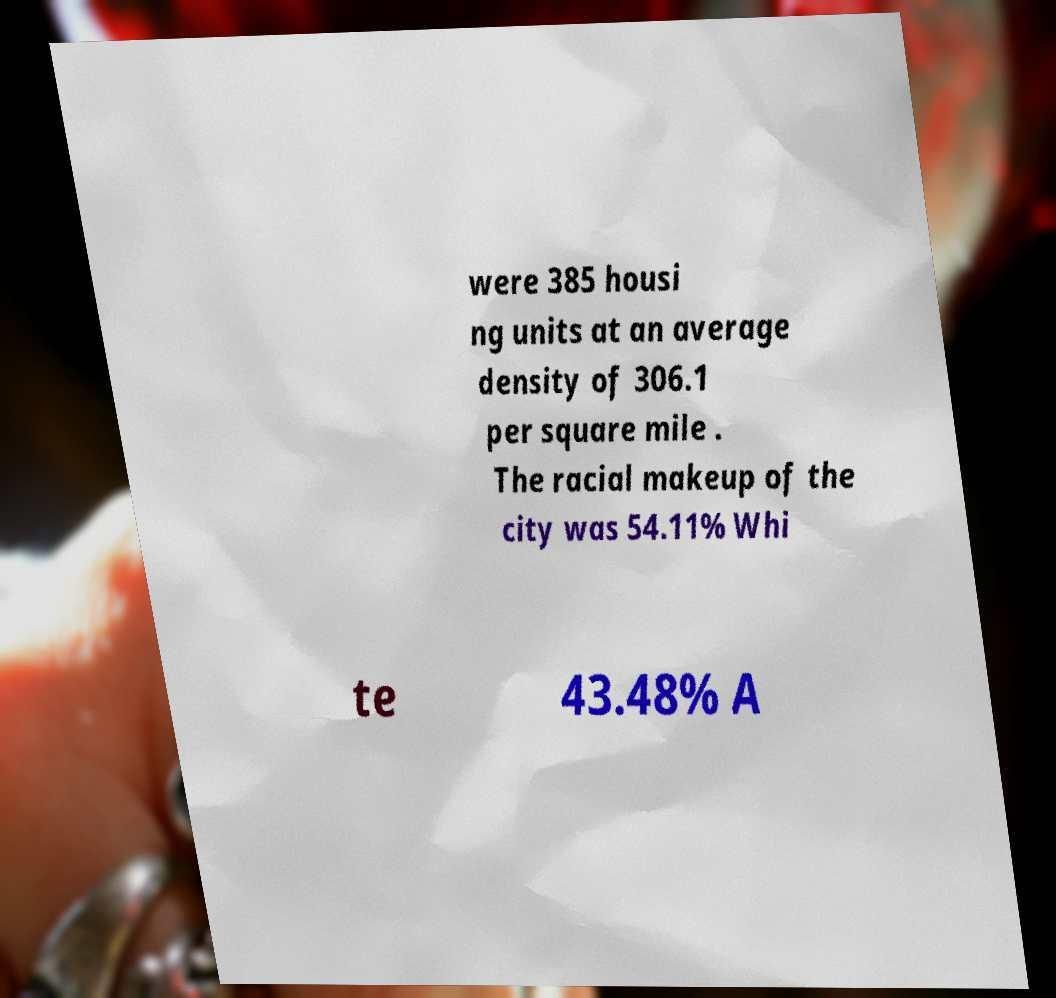What messages or text are displayed in this image? I need them in a readable, typed format. were 385 housi ng units at an average density of 306.1 per square mile . The racial makeup of the city was 54.11% Whi te 43.48% A 